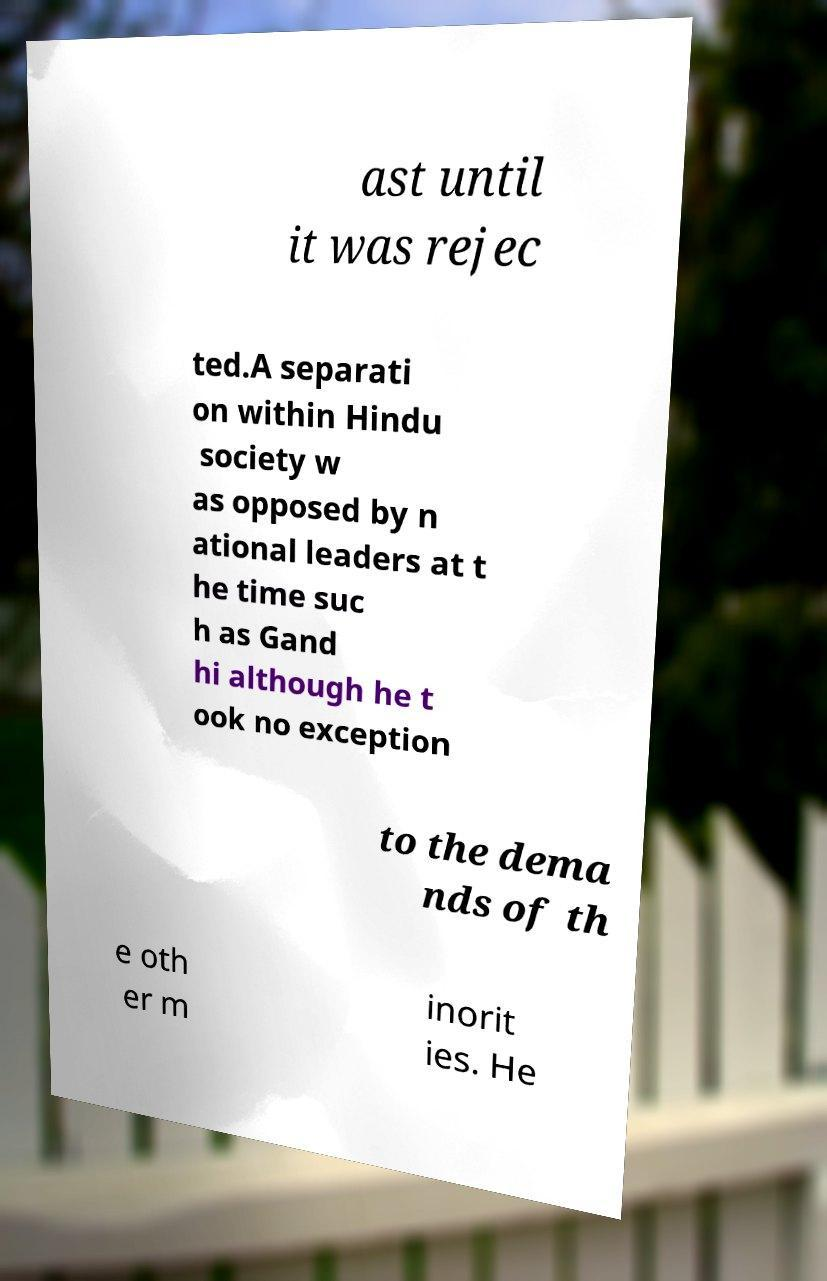Can you read and provide the text displayed in the image?This photo seems to have some interesting text. Can you extract and type it out for me? ast until it was rejec ted.A separati on within Hindu society w as opposed by n ational leaders at t he time suc h as Gand hi although he t ook no exception to the dema nds of th e oth er m inorit ies. He 